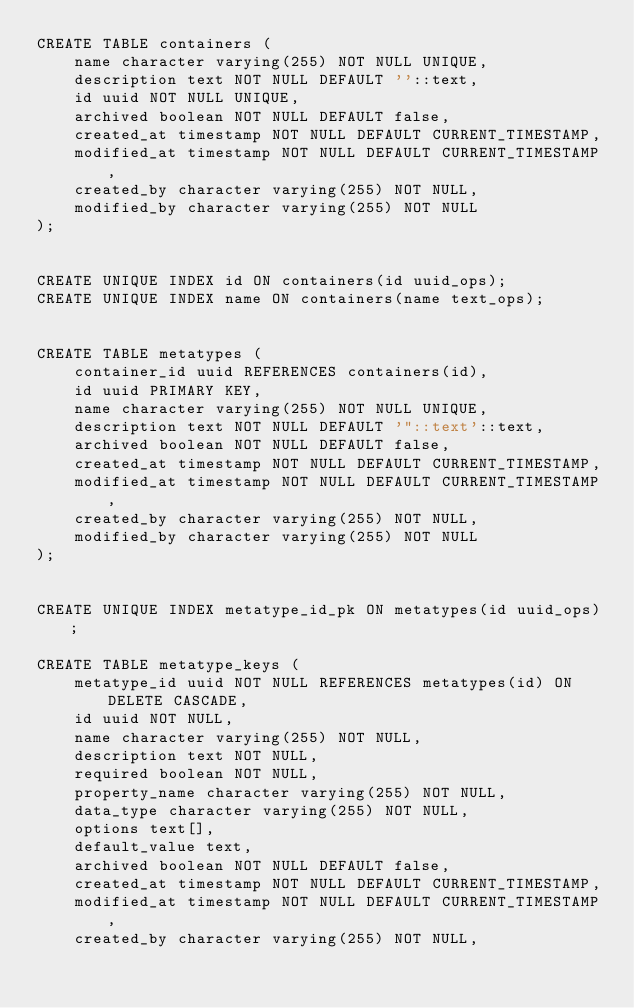Convert code to text. <code><loc_0><loc_0><loc_500><loc_500><_SQL_>CREATE TABLE containers (
    name character varying(255) NOT NULL UNIQUE,
    description text NOT NULL DEFAULT ''::text,
    id uuid NOT NULL UNIQUE,
    archived boolean NOT NULL DEFAULT false,
    created_at timestamp NOT NULL DEFAULT CURRENT_TIMESTAMP,
    modified_at timestamp NOT NULL DEFAULT CURRENT_TIMESTAMP,
    created_by character varying(255) NOT NULL,
    modified_by character varying(255) NOT NULL
);


CREATE UNIQUE INDEX id ON containers(id uuid_ops);
CREATE UNIQUE INDEX name ON containers(name text_ops);


CREATE TABLE metatypes (
    container_id uuid REFERENCES containers(id),
    id uuid PRIMARY KEY,
    name character varying(255) NOT NULL UNIQUE,
    description text NOT NULL DEFAULT '"::text'::text,
    archived boolean NOT NULL DEFAULT false,
    created_at timestamp NOT NULL DEFAULT CURRENT_TIMESTAMP,
    modified_at timestamp NOT NULL DEFAULT CURRENT_TIMESTAMP,
    created_by character varying(255) NOT NULL,
    modified_by character varying(255) NOT NULL
);


CREATE UNIQUE INDEX metatype_id_pk ON metatypes(id uuid_ops);

CREATE TABLE metatype_keys (
    metatype_id uuid NOT NULL REFERENCES metatypes(id) ON DELETE CASCADE,
    id uuid NOT NULL,
    name character varying(255) NOT NULL,
    description text NOT NULL,
    required boolean NOT NULL,
    property_name character varying(255) NOT NULL,
    data_type character varying(255) NOT NULL,
    options text[],
    default_value text,
    archived boolean NOT NULL DEFAULT false,
    created_at timestamp NOT NULL DEFAULT CURRENT_TIMESTAMP,
    modified_at timestamp NOT NULL DEFAULT CURRENT_TIMESTAMP,
    created_by character varying(255) NOT NULL,</code> 